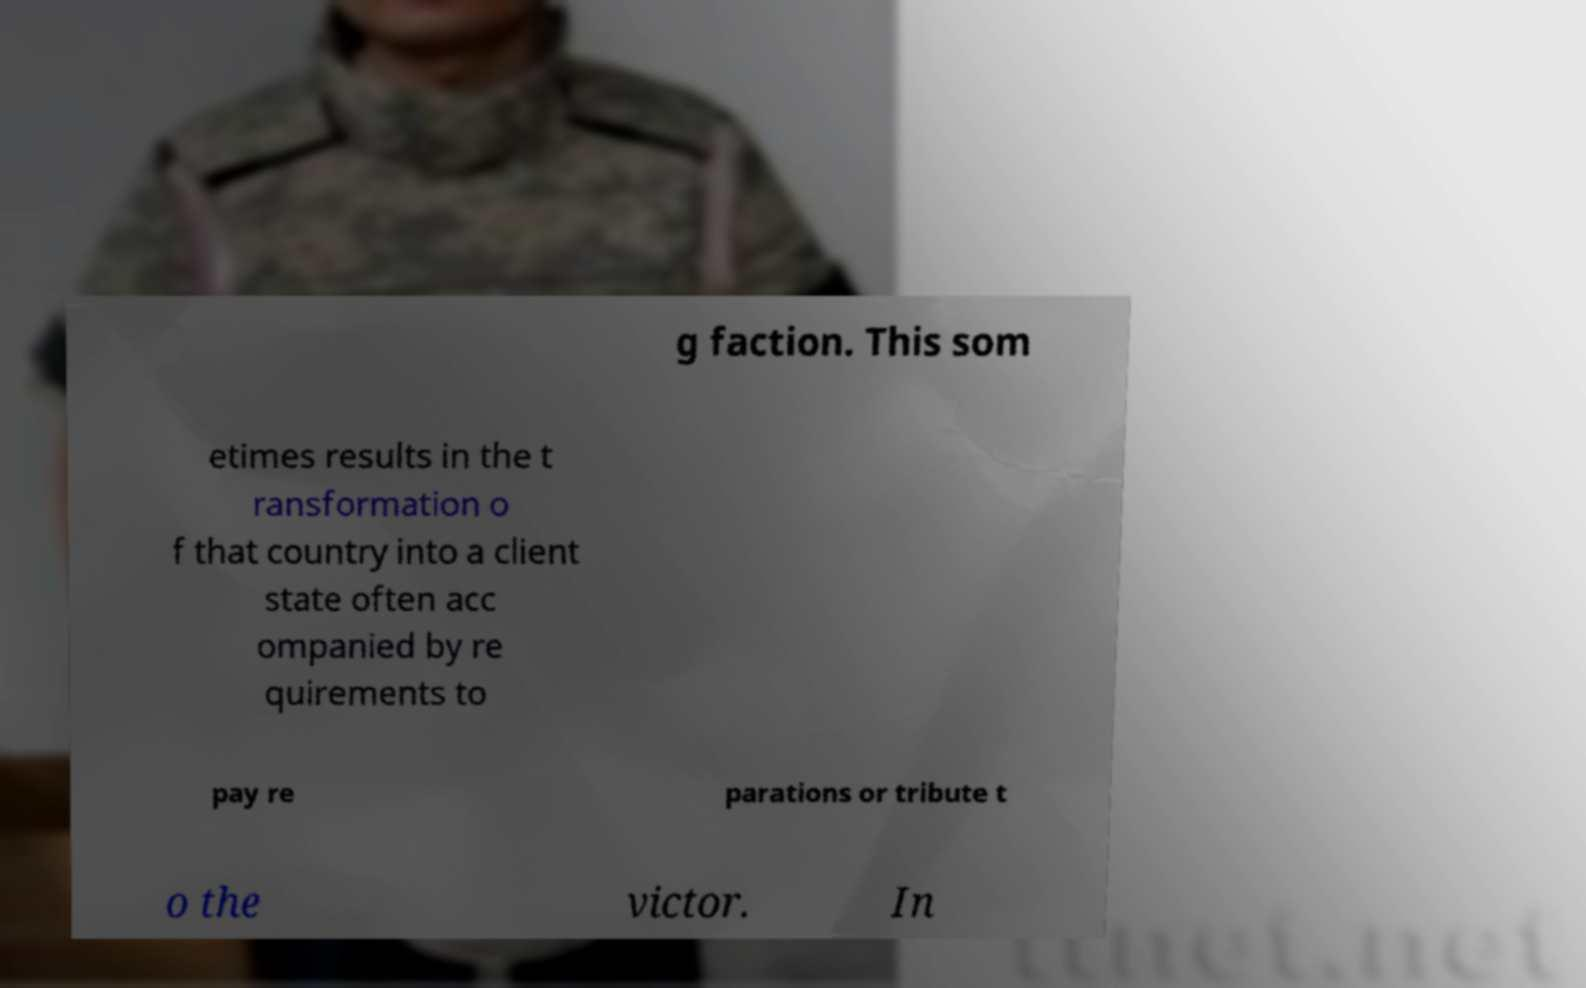Could you extract and type out the text from this image? g faction. This som etimes results in the t ransformation o f that country into a client state often acc ompanied by re quirements to pay re parations or tribute t o the victor. In 